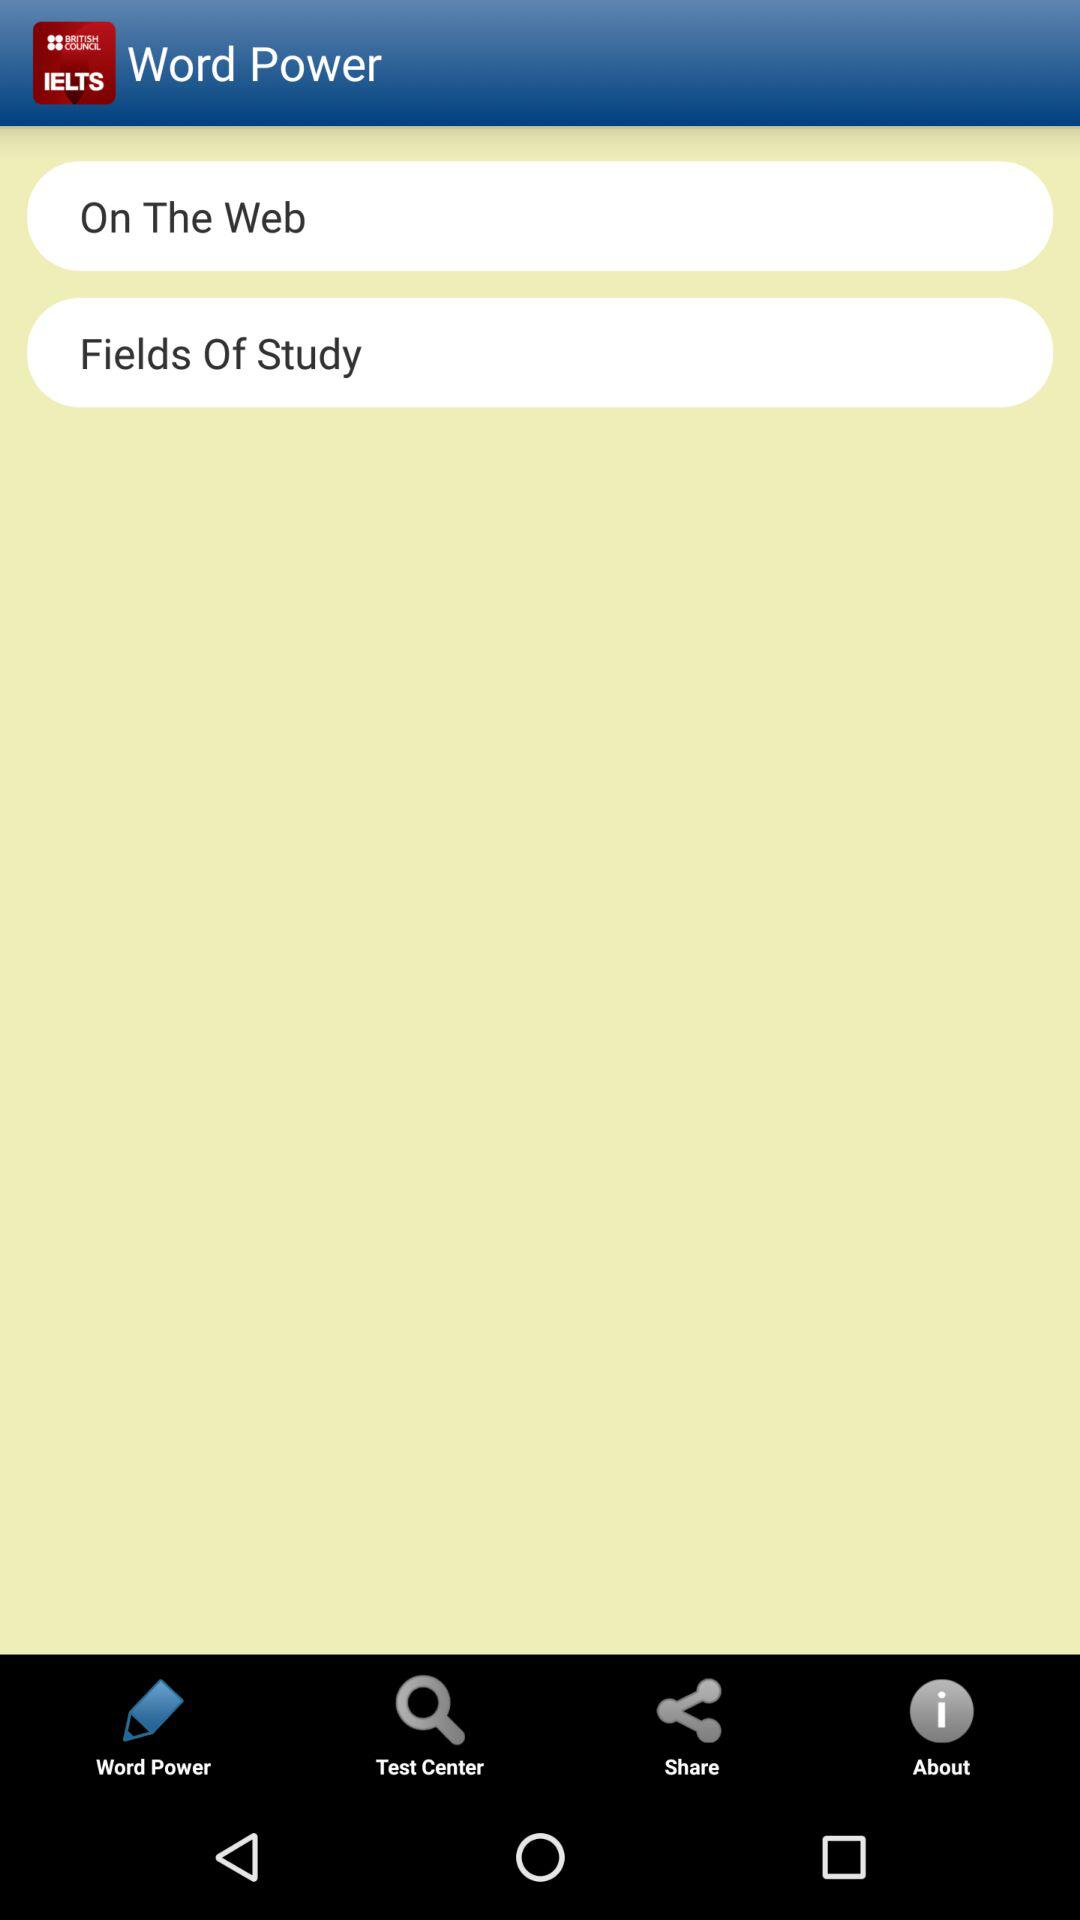What’s the app name? The app name is "Word Power". 